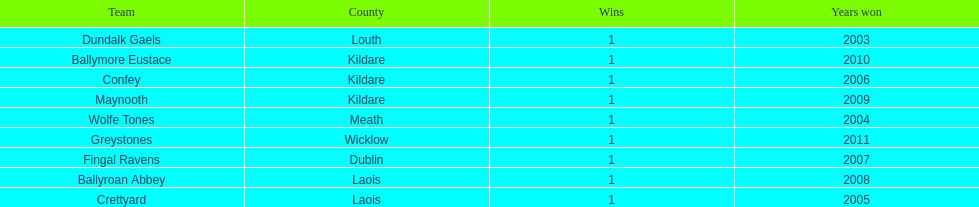What team comes before confey Fingal Ravens. 